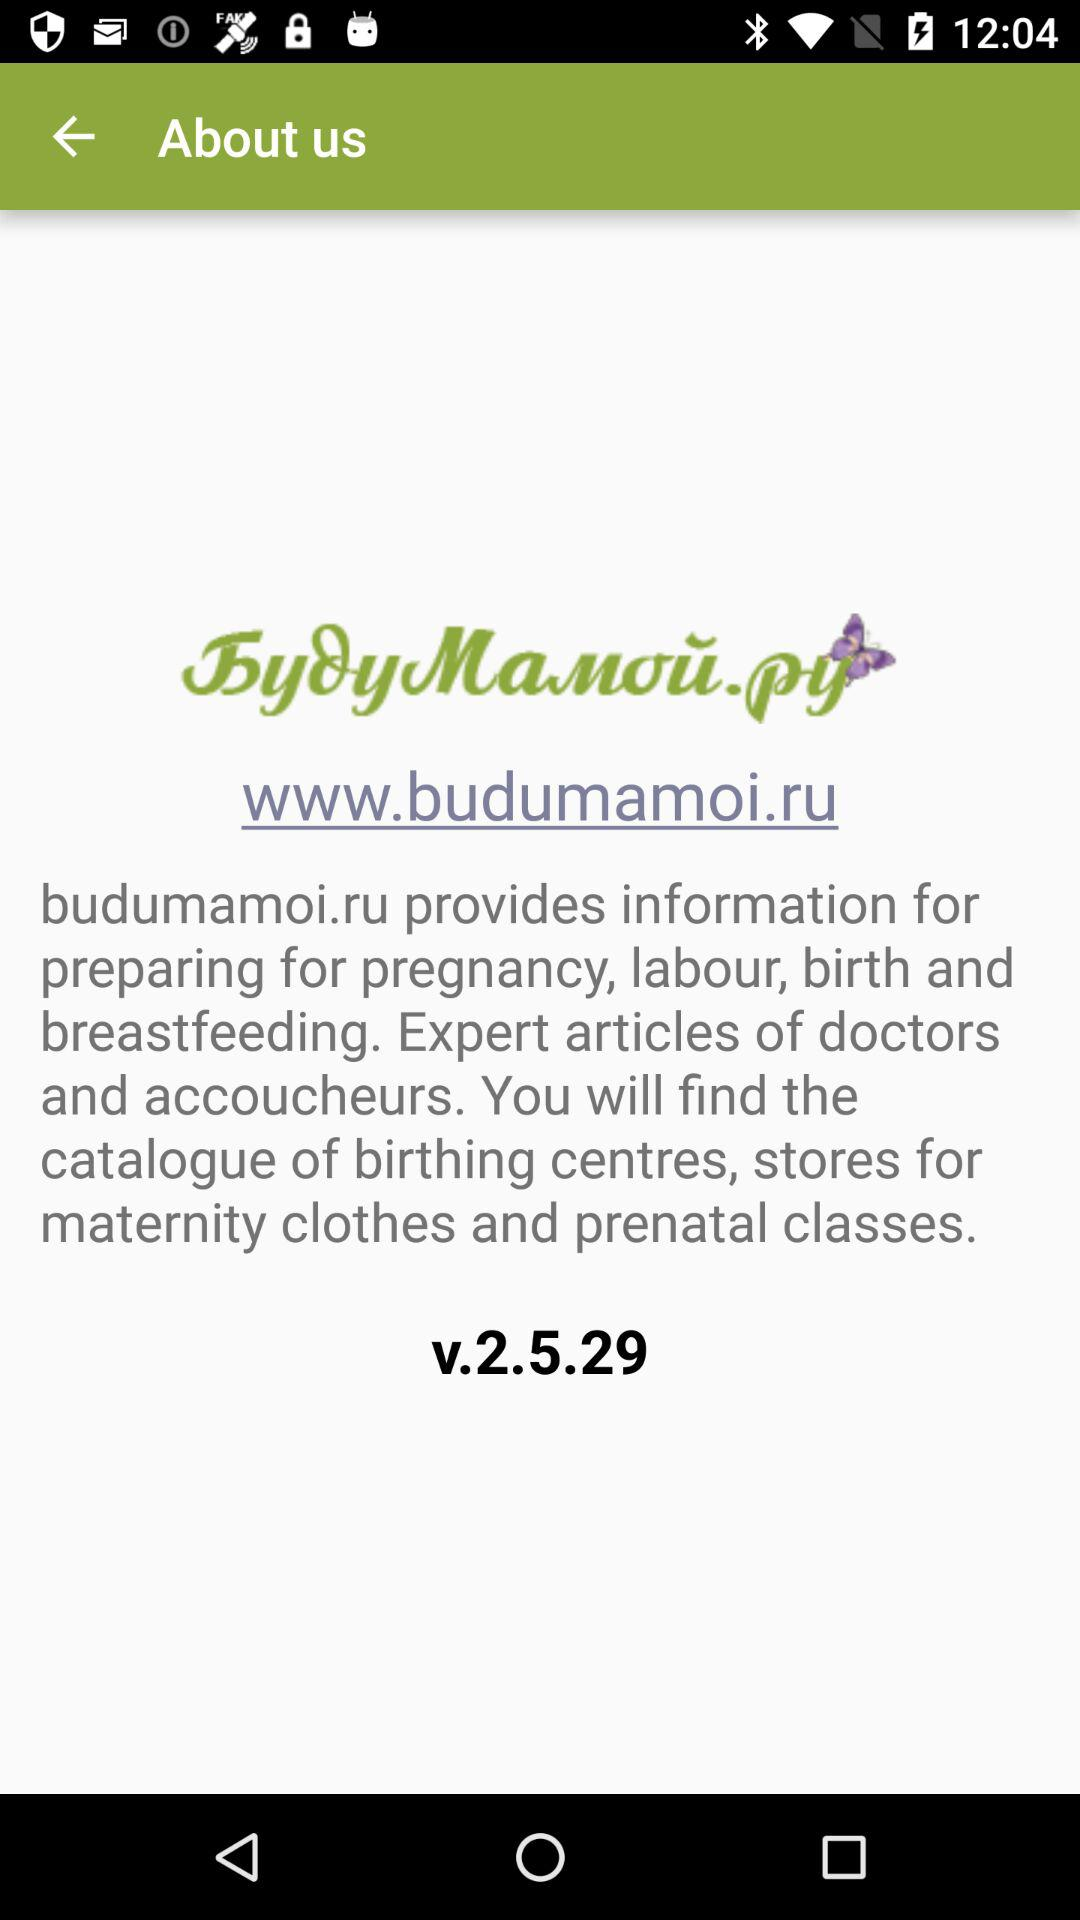What is the current version? The current version is v.2.5.29. 